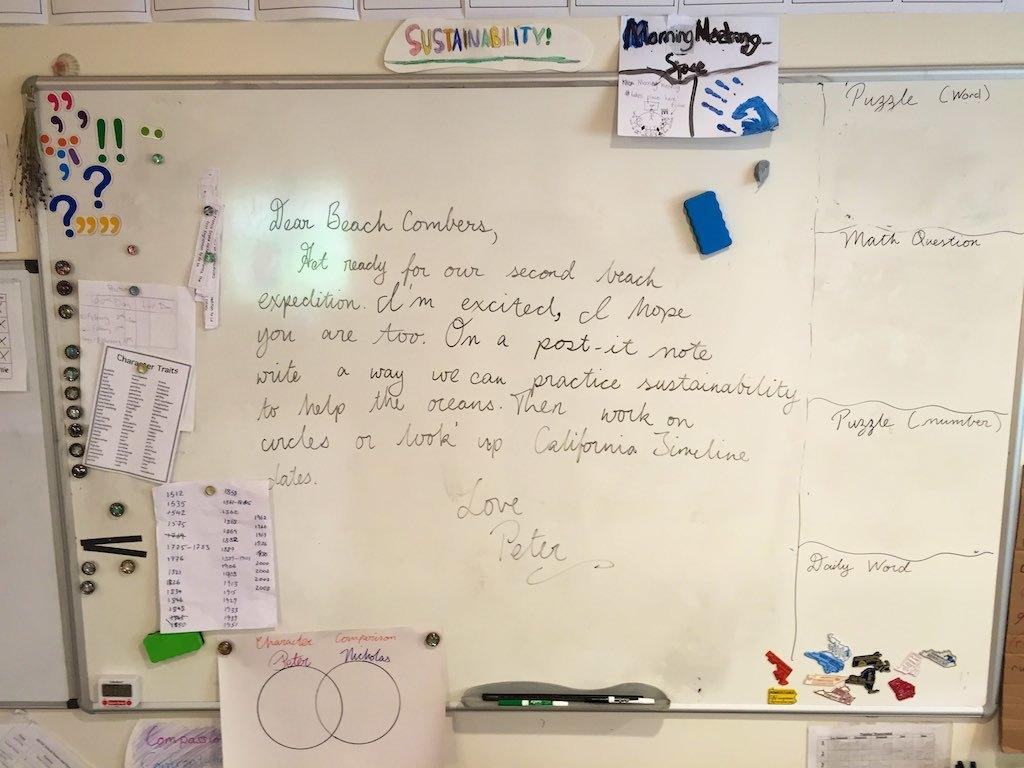Provide a one-sentence caption for the provided image. On a white, dry erase board, under the word sustainability, is an assignment geared towards sustainability for the ocean. 